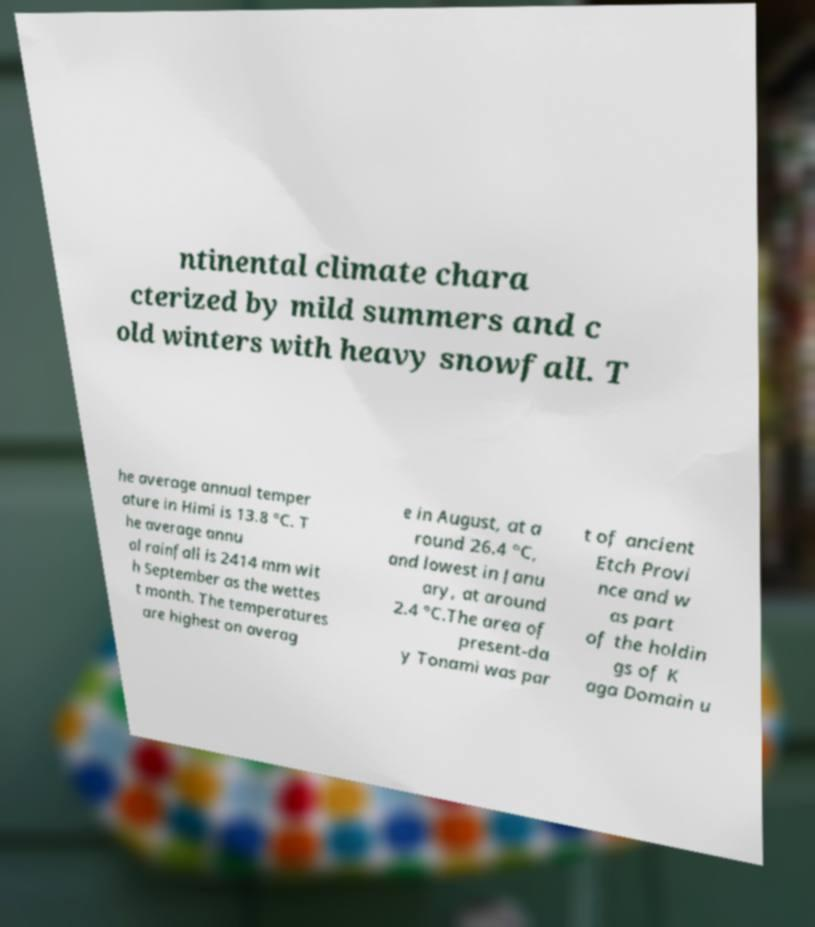Please read and relay the text visible in this image. What does it say? ntinental climate chara cterized by mild summers and c old winters with heavy snowfall. T he average annual temper ature in Himi is 13.8 °C. T he average annu al rainfall is 2414 mm wit h September as the wettes t month. The temperatures are highest on averag e in August, at a round 26.4 °C, and lowest in Janu ary, at around 2.4 °C.The area of present-da y Tonami was par t of ancient Etch Provi nce and w as part of the holdin gs of K aga Domain u 